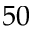<formula> <loc_0><loc_0><loc_500><loc_500>5 0</formula> 